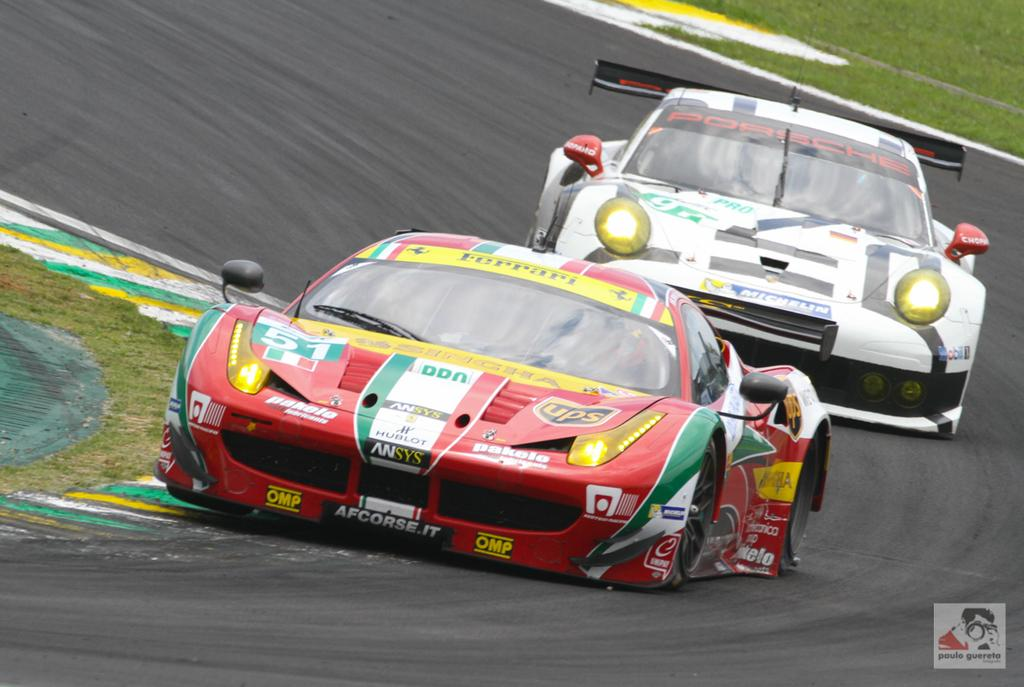What type of vehicles are in the image? There are sports or racing cars in the image. What colors are the cars? The cars are red and white in color. What is visible at the bottom of the image? There is a road visible at the bottom of the image. What type of vegetation is on both sides of the image? There is grass on the right side and the left side of the image. How many bikes are parked next to the grass on the right side of the image? There are no bikes present in the image; it features sports or racing cars and grass. Can you tell me the age of the baby sitting on the grass on the left side of the image? There is no baby present in the image; it features sports or racing cars and grass. 